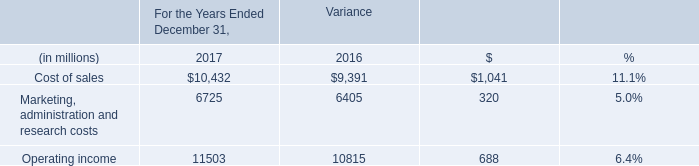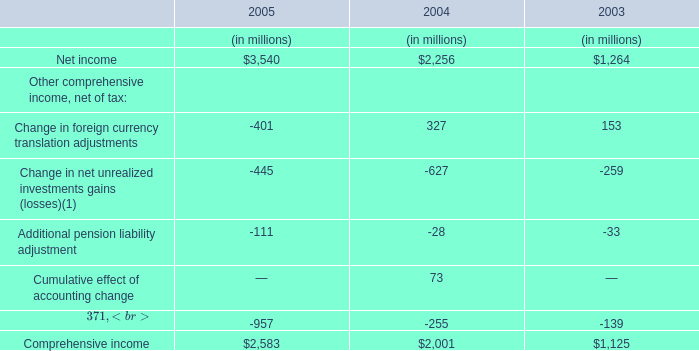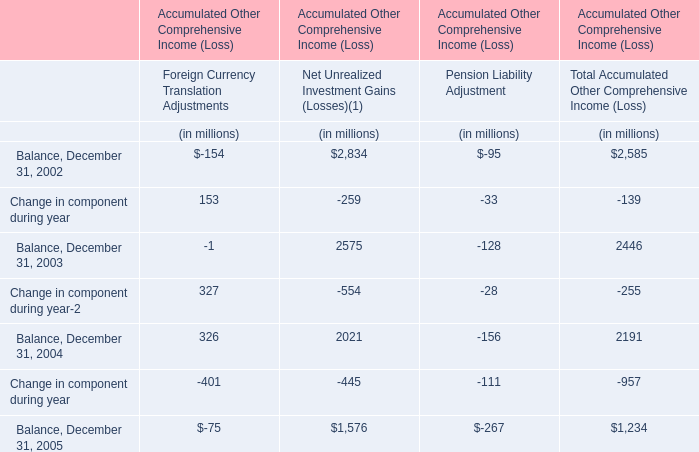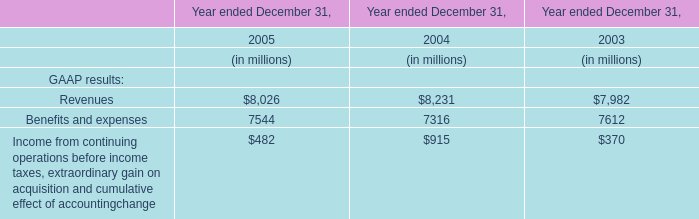In which year is Change in component during year in Foreign Currency Translation Adjustments positive? 
Answer: 2002 2003. 